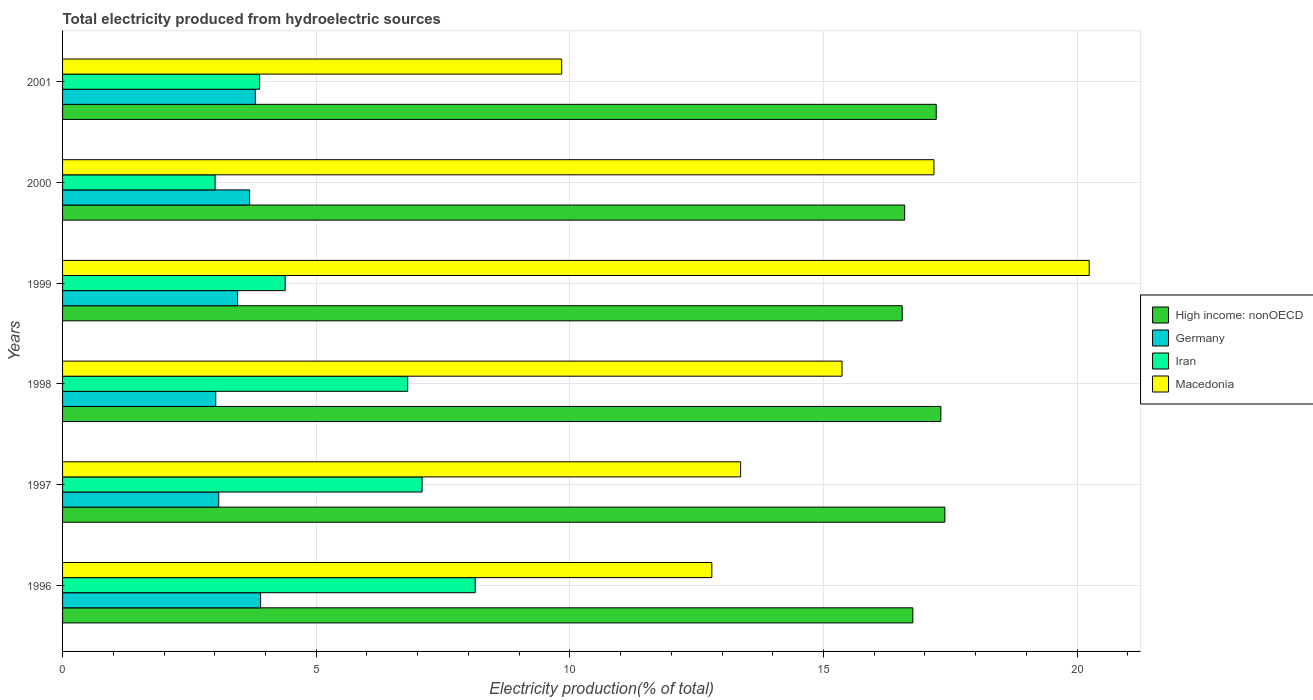Are the number of bars per tick equal to the number of legend labels?
Keep it short and to the point. Yes. Are the number of bars on each tick of the Y-axis equal?
Provide a succinct answer. Yes. How many bars are there on the 1st tick from the bottom?
Provide a succinct answer. 4. What is the label of the 1st group of bars from the top?
Provide a succinct answer. 2001. What is the total electricity produced in Iran in 2001?
Your answer should be compact. 3.88. Across all years, what is the maximum total electricity produced in High income: nonOECD?
Offer a terse response. 17.39. Across all years, what is the minimum total electricity produced in Macedonia?
Offer a very short reply. 9.84. What is the total total electricity produced in Germany in the graph?
Ensure brevity in your answer.  20.94. What is the difference between the total electricity produced in Iran in 1997 and that in 1999?
Your answer should be very brief. 2.7. What is the difference between the total electricity produced in Iran in 1996 and the total electricity produced in Germany in 2001?
Provide a succinct answer. 4.34. What is the average total electricity produced in Macedonia per year?
Your response must be concise. 14.8. In the year 1998, what is the difference between the total electricity produced in High income: nonOECD and total electricity produced in Macedonia?
Your response must be concise. 1.95. What is the ratio of the total electricity produced in High income: nonOECD in 1997 to that in 1999?
Ensure brevity in your answer.  1.05. What is the difference between the highest and the second highest total electricity produced in Macedonia?
Your response must be concise. 3.06. What is the difference between the highest and the lowest total electricity produced in Germany?
Your answer should be very brief. 0.88. In how many years, is the total electricity produced in Macedonia greater than the average total electricity produced in Macedonia taken over all years?
Keep it short and to the point. 3. Is the sum of the total electricity produced in Germany in 1998 and 1999 greater than the maximum total electricity produced in Iran across all years?
Provide a short and direct response. No. Is it the case that in every year, the sum of the total electricity produced in Iran and total electricity produced in Germany is greater than the sum of total electricity produced in Macedonia and total electricity produced in High income: nonOECD?
Your response must be concise. No. What does the 2nd bar from the top in 1998 represents?
Your answer should be very brief. Iran. What does the 4th bar from the bottom in 1996 represents?
Offer a very short reply. Macedonia. How many legend labels are there?
Provide a succinct answer. 4. What is the title of the graph?
Offer a very short reply. Total electricity produced from hydroelectric sources. Does "Sierra Leone" appear as one of the legend labels in the graph?
Your answer should be very brief. No. What is the Electricity production(% of total) in High income: nonOECD in 1996?
Keep it short and to the point. 16.76. What is the Electricity production(% of total) of Germany in 1996?
Offer a terse response. 3.9. What is the Electricity production(% of total) of Iran in 1996?
Your answer should be very brief. 8.13. What is the Electricity production(% of total) of Macedonia in 1996?
Give a very brief answer. 12.8. What is the Electricity production(% of total) of High income: nonOECD in 1997?
Provide a succinct answer. 17.39. What is the Electricity production(% of total) of Germany in 1997?
Offer a terse response. 3.08. What is the Electricity production(% of total) in Iran in 1997?
Make the answer very short. 7.09. What is the Electricity production(% of total) in Macedonia in 1997?
Offer a very short reply. 13.37. What is the Electricity production(% of total) of High income: nonOECD in 1998?
Offer a very short reply. 17.31. What is the Electricity production(% of total) in Germany in 1998?
Ensure brevity in your answer.  3.02. What is the Electricity production(% of total) in Iran in 1998?
Give a very brief answer. 6.8. What is the Electricity production(% of total) of Macedonia in 1998?
Make the answer very short. 15.37. What is the Electricity production(% of total) in High income: nonOECD in 1999?
Provide a short and direct response. 16.55. What is the Electricity production(% of total) in Germany in 1999?
Provide a short and direct response. 3.45. What is the Electricity production(% of total) in Iran in 1999?
Ensure brevity in your answer.  4.39. What is the Electricity production(% of total) of Macedonia in 1999?
Ensure brevity in your answer.  20.24. What is the Electricity production(% of total) of High income: nonOECD in 2000?
Make the answer very short. 16.6. What is the Electricity production(% of total) of Germany in 2000?
Make the answer very short. 3.69. What is the Electricity production(% of total) in Iran in 2000?
Ensure brevity in your answer.  3.01. What is the Electricity production(% of total) of Macedonia in 2000?
Offer a very short reply. 17.18. What is the Electricity production(% of total) in High income: nonOECD in 2001?
Offer a very short reply. 17.22. What is the Electricity production(% of total) in Germany in 2001?
Make the answer very short. 3.8. What is the Electricity production(% of total) of Iran in 2001?
Give a very brief answer. 3.88. What is the Electricity production(% of total) in Macedonia in 2001?
Keep it short and to the point. 9.84. Across all years, what is the maximum Electricity production(% of total) in High income: nonOECD?
Keep it short and to the point. 17.39. Across all years, what is the maximum Electricity production(% of total) in Germany?
Your answer should be compact. 3.9. Across all years, what is the maximum Electricity production(% of total) in Iran?
Offer a very short reply. 8.13. Across all years, what is the maximum Electricity production(% of total) in Macedonia?
Your answer should be very brief. 20.24. Across all years, what is the minimum Electricity production(% of total) of High income: nonOECD?
Your answer should be very brief. 16.55. Across all years, what is the minimum Electricity production(% of total) in Germany?
Your answer should be very brief. 3.02. Across all years, what is the minimum Electricity production(% of total) of Iran?
Give a very brief answer. 3.01. Across all years, what is the minimum Electricity production(% of total) in Macedonia?
Provide a short and direct response. 9.84. What is the total Electricity production(% of total) in High income: nonOECD in the graph?
Keep it short and to the point. 101.85. What is the total Electricity production(% of total) of Germany in the graph?
Provide a succinct answer. 20.94. What is the total Electricity production(% of total) of Iran in the graph?
Provide a succinct answer. 33.31. What is the total Electricity production(% of total) in Macedonia in the graph?
Your answer should be very brief. 88.79. What is the difference between the Electricity production(% of total) of High income: nonOECD in 1996 and that in 1997?
Offer a very short reply. -0.63. What is the difference between the Electricity production(% of total) in Germany in 1996 and that in 1997?
Give a very brief answer. 0.82. What is the difference between the Electricity production(% of total) of Iran in 1996 and that in 1997?
Ensure brevity in your answer.  1.05. What is the difference between the Electricity production(% of total) of Macedonia in 1996 and that in 1997?
Keep it short and to the point. -0.57. What is the difference between the Electricity production(% of total) of High income: nonOECD in 1996 and that in 1998?
Provide a short and direct response. -0.55. What is the difference between the Electricity production(% of total) in Germany in 1996 and that in 1998?
Make the answer very short. 0.88. What is the difference between the Electricity production(% of total) in Iran in 1996 and that in 1998?
Provide a succinct answer. 1.33. What is the difference between the Electricity production(% of total) of Macedonia in 1996 and that in 1998?
Make the answer very short. -2.57. What is the difference between the Electricity production(% of total) in High income: nonOECD in 1996 and that in 1999?
Ensure brevity in your answer.  0.21. What is the difference between the Electricity production(% of total) of Germany in 1996 and that in 1999?
Give a very brief answer. 0.45. What is the difference between the Electricity production(% of total) of Iran in 1996 and that in 1999?
Provide a succinct answer. 3.75. What is the difference between the Electricity production(% of total) of Macedonia in 1996 and that in 1999?
Offer a very short reply. -7.44. What is the difference between the Electricity production(% of total) of High income: nonOECD in 1996 and that in 2000?
Offer a very short reply. 0.16. What is the difference between the Electricity production(% of total) in Germany in 1996 and that in 2000?
Give a very brief answer. 0.22. What is the difference between the Electricity production(% of total) in Iran in 1996 and that in 2000?
Keep it short and to the point. 5.13. What is the difference between the Electricity production(% of total) of Macedonia in 1996 and that in 2000?
Offer a very short reply. -4.38. What is the difference between the Electricity production(% of total) in High income: nonOECD in 1996 and that in 2001?
Provide a succinct answer. -0.46. What is the difference between the Electricity production(% of total) in Germany in 1996 and that in 2001?
Make the answer very short. 0.1. What is the difference between the Electricity production(% of total) in Iran in 1996 and that in 2001?
Provide a short and direct response. 4.25. What is the difference between the Electricity production(% of total) in Macedonia in 1996 and that in 2001?
Your answer should be compact. 2.96. What is the difference between the Electricity production(% of total) of High income: nonOECD in 1997 and that in 1998?
Offer a very short reply. 0.08. What is the difference between the Electricity production(% of total) in Germany in 1997 and that in 1998?
Provide a short and direct response. 0.06. What is the difference between the Electricity production(% of total) in Iran in 1997 and that in 1998?
Give a very brief answer. 0.28. What is the difference between the Electricity production(% of total) in Macedonia in 1997 and that in 1998?
Your answer should be very brief. -2. What is the difference between the Electricity production(% of total) of High income: nonOECD in 1997 and that in 1999?
Provide a succinct answer. 0.84. What is the difference between the Electricity production(% of total) of Germany in 1997 and that in 1999?
Your answer should be very brief. -0.37. What is the difference between the Electricity production(% of total) in Iran in 1997 and that in 1999?
Make the answer very short. 2.7. What is the difference between the Electricity production(% of total) of Macedonia in 1997 and that in 1999?
Offer a very short reply. -6.87. What is the difference between the Electricity production(% of total) of High income: nonOECD in 1997 and that in 2000?
Offer a terse response. 0.79. What is the difference between the Electricity production(% of total) in Germany in 1997 and that in 2000?
Make the answer very short. -0.61. What is the difference between the Electricity production(% of total) in Iran in 1997 and that in 2000?
Provide a short and direct response. 4.08. What is the difference between the Electricity production(% of total) in Macedonia in 1997 and that in 2000?
Give a very brief answer. -3.81. What is the difference between the Electricity production(% of total) of High income: nonOECD in 1997 and that in 2001?
Provide a short and direct response. 0.17. What is the difference between the Electricity production(% of total) of Germany in 1997 and that in 2001?
Ensure brevity in your answer.  -0.72. What is the difference between the Electricity production(% of total) in Iran in 1997 and that in 2001?
Your response must be concise. 3.2. What is the difference between the Electricity production(% of total) in Macedonia in 1997 and that in 2001?
Offer a very short reply. 3.53. What is the difference between the Electricity production(% of total) in High income: nonOECD in 1998 and that in 1999?
Give a very brief answer. 0.76. What is the difference between the Electricity production(% of total) of Germany in 1998 and that in 1999?
Your answer should be very brief. -0.43. What is the difference between the Electricity production(% of total) of Iran in 1998 and that in 1999?
Your response must be concise. 2.42. What is the difference between the Electricity production(% of total) of Macedonia in 1998 and that in 1999?
Make the answer very short. -4.87. What is the difference between the Electricity production(% of total) of High income: nonOECD in 1998 and that in 2000?
Your response must be concise. 0.71. What is the difference between the Electricity production(% of total) of Germany in 1998 and that in 2000?
Offer a very short reply. -0.67. What is the difference between the Electricity production(% of total) of Iran in 1998 and that in 2000?
Offer a very short reply. 3.8. What is the difference between the Electricity production(% of total) of Macedonia in 1998 and that in 2000?
Provide a succinct answer. -1.81. What is the difference between the Electricity production(% of total) of High income: nonOECD in 1998 and that in 2001?
Offer a terse response. 0.09. What is the difference between the Electricity production(% of total) in Germany in 1998 and that in 2001?
Ensure brevity in your answer.  -0.78. What is the difference between the Electricity production(% of total) of Iran in 1998 and that in 2001?
Keep it short and to the point. 2.92. What is the difference between the Electricity production(% of total) in Macedonia in 1998 and that in 2001?
Give a very brief answer. 5.53. What is the difference between the Electricity production(% of total) in High income: nonOECD in 1999 and that in 2000?
Make the answer very short. -0.05. What is the difference between the Electricity production(% of total) of Germany in 1999 and that in 2000?
Offer a terse response. -0.24. What is the difference between the Electricity production(% of total) of Iran in 1999 and that in 2000?
Offer a terse response. 1.38. What is the difference between the Electricity production(% of total) of Macedonia in 1999 and that in 2000?
Give a very brief answer. 3.06. What is the difference between the Electricity production(% of total) in High income: nonOECD in 1999 and that in 2001?
Make the answer very short. -0.67. What is the difference between the Electricity production(% of total) of Germany in 1999 and that in 2001?
Offer a very short reply. -0.35. What is the difference between the Electricity production(% of total) in Iran in 1999 and that in 2001?
Offer a very short reply. 0.5. What is the difference between the Electricity production(% of total) of Macedonia in 1999 and that in 2001?
Your answer should be very brief. 10.4. What is the difference between the Electricity production(% of total) of High income: nonOECD in 2000 and that in 2001?
Your answer should be compact. -0.62. What is the difference between the Electricity production(% of total) of Germany in 2000 and that in 2001?
Ensure brevity in your answer.  -0.11. What is the difference between the Electricity production(% of total) in Iran in 2000 and that in 2001?
Give a very brief answer. -0.88. What is the difference between the Electricity production(% of total) of Macedonia in 2000 and that in 2001?
Offer a terse response. 7.34. What is the difference between the Electricity production(% of total) of High income: nonOECD in 1996 and the Electricity production(% of total) of Germany in 1997?
Provide a short and direct response. 13.68. What is the difference between the Electricity production(% of total) in High income: nonOECD in 1996 and the Electricity production(% of total) in Iran in 1997?
Your response must be concise. 9.67. What is the difference between the Electricity production(% of total) in High income: nonOECD in 1996 and the Electricity production(% of total) in Macedonia in 1997?
Keep it short and to the point. 3.39. What is the difference between the Electricity production(% of total) of Germany in 1996 and the Electricity production(% of total) of Iran in 1997?
Your response must be concise. -3.18. What is the difference between the Electricity production(% of total) in Germany in 1996 and the Electricity production(% of total) in Macedonia in 1997?
Your answer should be very brief. -9.46. What is the difference between the Electricity production(% of total) in Iran in 1996 and the Electricity production(% of total) in Macedonia in 1997?
Provide a short and direct response. -5.23. What is the difference between the Electricity production(% of total) of High income: nonOECD in 1996 and the Electricity production(% of total) of Germany in 1998?
Ensure brevity in your answer.  13.74. What is the difference between the Electricity production(% of total) of High income: nonOECD in 1996 and the Electricity production(% of total) of Iran in 1998?
Offer a very short reply. 9.96. What is the difference between the Electricity production(% of total) of High income: nonOECD in 1996 and the Electricity production(% of total) of Macedonia in 1998?
Provide a succinct answer. 1.4. What is the difference between the Electricity production(% of total) in Germany in 1996 and the Electricity production(% of total) in Iran in 1998?
Ensure brevity in your answer.  -2.9. What is the difference between the Electricity production(% of total) in Germany in 1996 and the Electricity production(% of total) in Macedonia in 1998?
Ensure brevity in your answer.  -11.46. What is the difference between the Electricity production(% of total) in Iran in 1996 and the Electricity production(% of total) in Macedonia in 1998?
Provide a succinct answer. -7.23. What is the difference between the Electricity production(% of total) in High income: nonOECD in 1996 and the Electricity production(% of total) in Germany in 1999?
Your answer should be very brief. 13.31. What is the difference between the Electricity production(% of total) of High income: nonOECD in 1996 and the Electricity production(% of total) of Iran in 1999?
Offer a terse response. 12.37. What is the difference between the Electricity production(% of total) in High income: nonOECD in 1996 and the Electricity production(% of total) in Macedonia in 1999?
Provide a short and direct response. -3.48. What is the difference between the Electricity production(% of total) of Germany in 1996 and the Electricity production(% of total) of Iran in 1999?
Provide a short and direct response. -0.48. What is the difference between the Electricity production(% of total) in Germany in 1996 and the Electricity production(% of total) in Macedonia in 1999?
Provide a succinct answer. -16.34. What is the difference between the Electricity production(% of total) in Iran in 1996 and the Electricity production(% of total) in Macedonia in 1999?
Make the answer very short. -12.1. What is the difference between the Electricity production(% of total) of High income: nonOECD in 1996 and the Electricity production(% of total) of Germany in 2000?
Your answer should be compact. 13.07. What is the difference between the Electricity production(% of total) of High income: nonOECD in 1996 and the Electricity production(% of total) of Iran in 2000?
Make the answer very short. 13.75. What is the difference between the Electricity production(% of total) in High income: nonOECD in 1996 and the Electricity production(% of total) in Macedonia in 2000?
Your response must be concise. -0.42. What is the difference between the Electricity production(% of total) of Germany in 1996 and the Electricity production(% of total) of Iran in 2000?
Your answer should be compact. 0.9. What is the difference between the Electricity production(% of total) in Germany in 1996 and the Electricity production(% of total) in Macedonia in 2000?
Your answer should be compact. -13.27. What is the difference between the Electricity production(% of total) in Iran in 1996 and the Electricity production(% of total) in Macedonia in 2000?
Ensure brevity in your answer.  -9.04. What is the difference between the Electricity production(% of total) in High income: nonOECD in 1996 and the Electricity production(% of total) in Germany in 2001?
Offer a very short reply. 12.96. What is the difference between the Electricity production(% of total) of High income: nonOECD in 1996 and the Electricity production(% of total) of Iran in 2001?
Offer a very short reply. 12.88. What is the difference between the Electricity production(% of total) in High income: nonOECD in 1996 and the Electricity production(% of total) in Macedonia in 2001?
Offer a very short reply. 6.92. What is the difference between the Electricity production(% of total) in Germany in 1996 and the Electricity production(% of total) in Iran in 2001?
Give a very brief answer. 0.02. What is the difference between the Electricity production(% of total) in Germany in 1996 and the Electricity production(% of total) in Macedonia in 2001?
Offer a terse response. -5.94. What is the difference between the Electricity production(% of total) in Iran in 1996 and the Electricity production(% of total) in Macedonia in 2001?
Offer a very short reply. -1.7. What is the difference between the Electricity production(% of total) in High income: nonOECD in 1997 and the Electricity production(% of total) in Germany in 1998?
Your answer should be very brief. 14.37. What is the difference between the Electricity production(% of total) in High income: nonOECD in 1997 and the Electricity production(% of total) in Iran in 1998?
Offer a very short reply. 10.59. What is the difference between the Electricity production(% of total) of High income: nonOECD in 1997 and the Electricity production(% of total) of Macedonia in 1998?
Give a very brief answer. 2.03. What is the difference between the Electricity production(% of total) in Germany in 1997 and the Electricity production(% of total) in Iran in 1998?
Keep it short and to the point. -3.73. What is the difference between the Electricity production(% of total) in Germany in 1997 and the Electricity production(% of total) in Macedonia in 1998?
Your answer should be compact. -12.29. What is the difference between the Electricity production(% of total) of Iran in 1997 and the Electricity production(% of total) of Macedonia in 1998?
Make the answer very short. -8.28. What is the difference between the Electricity production(% of total) in High income: nonOECD in 1997 and the Electricity production(% of total) in Germany in 1999?
Your response must be concise. 13.94. What is the difference between the Electricity production(% of total) in High income: nonOECD in 1997 and the Electricity production(% of total) in Iran in 1999?
Your answer should be compact. 13.01. What is the difference between the Electricity production(% of total) in High income: nonOECD in 1997 and the Electricity production(% of total) in Macedonia in 1999?
Your response must be concise. -2.85. What is the difference between the Electricity production(% of total) of Germany in 1997 and the Electricity production(% of total) of Iran in 1999?
Ensure brevity in your answer.  -1.31. What is the difference between the Electricity production(% of total) of Germany in 1997 and the Electricity production(% of total) of Macedonia in 1999?
Offer a terse response. -17.16. What is the difference between the Electricity production(% of total) of Iran in 1997 and the Electricity production(% of total) of Macedonia in 1999?
Your response must be concise. -13.15. What is the difference between the Electricity production(% of total) in High income: nonOECD in 1997 and the Electricity production(% of total) in Germany in 2000?
Give a very brief answer. 13.71. What is the difference between the Electricity production(% of total) in High income: nonOECD in 1997 and the Electricity production(% of total) in Iran in 2000?
Offer a terse response. 14.39. What is the difference between the Electricity production(% of total) in High income: nonOECD in 1997 and the Electricity production(% of total) in Macedonia in 2000?
Make the answer very short. 0.22. What is the difference between the Electricity production(% of total) of Germany in 1997 and the Electricity production(% of total) of Iran in 2000?
Offer a very short reply. 0.07. What is the difference between the Electricity production(% of total) of Germany in 1997 and the Electricity production(% of total) of Macedonia in 2000?
Provide a short and direct response. -14.1. What is the difference between the Electricity production(% of total) in Iran in 1997 and the Electricity production(% of total) in Macedonia in 2000?
Your answer should be very brief. -10.09. What is the difference between the Electricity production(% of total) of High income: nonOECD in 1997 and the Electricity production(% of total) of Germany in 2001?
Keep it short and to the point. 13.59. What is the difference between the Electricity production(% of total) in High income: nonOECD in 1997 and the Electricity production(% of total) in Iran in 2001?
Give a very brief answer. 13.51. What is the difference between the Electricity production(% of total) of High income: nonOECD in 1997 and the Electricity production(% of total) of Macedonia in 2001?
Offer a very short reply. 7.55. What is the difference between the Electricity production(% of total) of Germany in 1997 and the Electricity production(% of total) of Iran in 2001?
Your response must be concise. -0.81. What is the difference between the Electricity production(% of total) in Germany in 1997 and the Electricity production(% of total) in Macedonia in 2001?
Ensure brevity in your answer.  -6.76. What is the difference between the Electricity production(% of total) of Iran in 1997 and the Electricity production(% of total) of Macedonia in 2001?
Your answer should be very brief. -2.75. What is the difference between the Electricity production(% of total) of High income: nonOECD in 1998 and the Electricity production(% of total) of Germany in 1999?
Make the answer very short. 13.86. What is the difference between the Electricity production(% of total) in High income: nonOECD in 1998 and the Electricity production(% of total) in Iran in 1999?
Make the answer very short. 12.93. What is the difference between the Electricity production(% of total) of High income: nonOECD in 1998 and the Electricity production(% of total) of Macedonia in 1999?
Your response must be concise. -2.93. What is the difference between the Electricity production(% of total) in Germany in 1998 and the Electricity production(% of total) in Iran in 1999?
Your response must be concise. -1.37. What is the difference between the Electricity production(% of total) in Germany in 1998 and the Electricity production(% of total) in Macedonia in 1999?
Make the answer very short. -17.22. What is the difference between the Electricity production(% of total) of Iran in 1998 and the Electricity production(% of total) of Macedonia in 1999?
Your answer should be very brief. -13.43. What is the difference between the Electricity production(% of total) in High income: nonOECD in 1998 and the Electricity production(% of total) in Germany in 2000?
Provide a succinct answer. 13.63. What is the difference between the Electricity production(% of total) of High income: nonOECD in 1998 and the Electricity production(% of total) of Iran in 2000?
Give a very brief answer. 14.31. What is the difference between the Electricity production(% of total) in High income: nonOECD in 1998 and the Electricity production(% of total) in Macedonia in 2000?
Your answer should be very brief. 0.14. What is the difference between the Electricity production(% of total) in Germany in 1998 and the Electricity production(% of total) in Iran in 2000?
Provide a succinct answer. 0.01. What is the difference between the Electricity production(% of total) in Germany in 1998 and the Electricity production(% of total) in Macedonia in 2000?
Your answer should be compact. -14.16. What is the difference between the Electricity production(% of total) of Iran in 1998 and the Electricity production(% of total) of Macedonia in 2000?
Keep it short and to the point. -10.37. What is the difference between the Electricity production(% of total) in High income: nonOECD in 1998 and the Electricity production(% of total) in Germany in 2001?
Ensure brevity in your answer.  13.51. What is the difference between the Electricity production(% of total) in High income: nonOECD in 1998 and the Electricity production(% of total) in Iran in 2001?
Offer a terse response. 13.43. What is the difference between the Electricity production(% of total) in High income: nonOECD in 1998 and the Electricity production(% of total) in Macedonia in 2001?
Your answer should be compact. 7.47. What is the difference between the Electricity production(% of total) in Germany in 1998 and the Electricity production(% of total) in Iran in 2001?
Keep it short and to the point. -0.86. What is the difference between the Electricity production(% of total) of Germany in 1998 and the Electricity production(% of total) of Macedonia in 2001?
Offer a terse response. -6.82. What is the difference between the Electricity production(% of total) of Iran in 1998 and the Electricity production(% of total) of Macedonia in 2001?
Make the answer very short. -3.04. What is the difference between the Electricity production(% of total) of High income: nonOECD in 1999 and the Electricity production(% of total) of Germany in 2000?
Ensure brevity in your answer.  12.87. What is the difference between the Electricity production(% of total) of High income: nonOECD in 1999 and the Electricity production(% of total) of Iran in 2000?
Make the answer very short. 13.55. What is the difference between the Electricity production(% of total) of High income: nonOECD in 1999 and the Electricity production(% of total) of Macedonia in 2000?
Provide a succinct answer. -0.62. What is the difference between the Electricity production(% of total) in Germany in 1999 and the Electricity production(% of total) in Iran in 2000?
Ensure brevity in your answer.  0.44. What is the difference between the Electricity production(% of total) of Germany in 1999 and the Electricity production(% of total) of Macedonia in 2000?
Keep it short and to the point. -13.73. What is the difference between the Electricity production(% of total) in Iran in 1999 and the Electricity production(% of total) in Macedonia in 2000?
Keep it short and to the point. -12.79. What is the difference between the Electricity production(% of total) in High income: nonOECD in 1999 and the Electricity production(% of total) in Germany in 2001?
Provide a short and direct response. 12.75. What is the difference between the Electricity production(% of total) of High income: nonOECD in 1999 and the Electricity production(% of total) of Iran in 2001?
Your response must be concise. 12.67. What is the difference between the Electricity production(% of total) in High income: nonOECD in 1999 and the Electricity production(% of total) in Macedonia in 2001?
Offer a terse response. 6.71. What is the difference between the Electricity production(% of total) in Germany in 1999 and the Electricity production(% of total) in Iran in 2001?
Provide a short and direct response. -0.43. What is the difference between the Electricity production(% of total) of Germany in 1999 and the Electricity production(% of total) of Macedonia in 2001?
Your answer should be very brief. -6.39. What is the difference between the Electricity production(% of total) in Iran in 1999 and the Electricity production(% of total) in Macedonia in 2001?
Ensure brevity in your answer.  -5.45. What is the difference between the Electricity production(% of total) of High income: nonOECD in 2000 and the Electricity production(% of total) of Germany in 2001?
Offer a very short reply. 12.8. What is the difference between the Electricity production(% of total) of High income: nonOECD in 2000 and the Electricity production(% of total) of Iran in 2001?
Ensure brevity in your answer.  12.72. What is the difference between the Electricity production(% of total) in High income: nonOECD in 2000 and the Electricity production(% of total) in Macedonia in 2001?
Your response must be concise. 6.76. What is the difference between the Electricity production(% of total) in Germany in 2000 and the Electricity production(% of total) in Iran in 2001?
Provide a succinct answer. -0.2. What is the difference between the Electricity production(% of total) in Germany in 2000 and the Electricity production(% of total) in Macedonia in 2001?
Keep it short and to the point. -6.15. What is the difference between the Electricity production(% of total) in Iran in 2000 and the Electricity production(% of total) in Macedonia in 2001?
Provide a succinct answer. -6.83. What is the average Electricity production(% of total) of High income: nonOECD per year?
Provide a succinct answer. 16.97. What is the average Electricity production(% of total) of Germany per year?
Ensure brevity in your answer.  3.49. What is the average Electricity production(% of total) in Iran per year?
Offer a terse response. 5.55. What is the average Electricity production(% of total) in Macedonia per year?
Keep it short and to the point. 14.8. In the year 1996, what is the difference between the Electricity production(% of total) in High income: nonOECD and Electricity production(% of total) in Germany?
Provide a short and direct response. 12.86. In the year 1996, what is the difference between the Electricity production(% of total) of High income: nonOECD and Electricity production(% of total) of Iran?
Keep it short and to the point. 8.63. In the year 1996, what is the difference between the Electricity production(% of total) in High income: nonOECD and Electricity production(% of total) in Macedonia?
Provide a succinct answer. 3.96. In the year 1996, what is the difference between the Electricity production(% of total) in Germany and Electricity production(% of total) in Iran?
Keep it short and to the point. -4.23. In the year 1996, what is the difference between the Electricity production(% of total) of Germany and Electricity production(% of total) of Macedonia?
Provide a short and direct response. -8.9. In the year 1996, what is the difference between the Electricity production(% of total) of Iran and Electricity production(% of total) of Macedonia?
Your response must be concise. -4.66. In the year 1997, what is the difference between the Electricity production(% of total) in High income: nonOECD and Electricity production(% of total) in Germany?
Give a very brief answer. 14.31. In the year 1997, what is the difference between the Electricity production(% of total) of High income: nonOECD and Electricity production(% of total) of Iran?
Your answer should be very brief. 10.31. In the year 1997, what is the difference between the Electricity production(% of total) in High income: nonOECD and Electricity production(% of total) in Macedonia?
Offer a terse response. 4.03. In the year 1997, what is the difference between the Electricity production(% of total) of Germany and Electricity production(% of total) of Iran?
Give a very brief answer. -4.01. In the year 1997, what is the difference between the Electricity production(% of total) of Germany and Electricity production(% of total) of Macedonia?
Your response must be concise. -10.29. In the year 1997, what is the difference between the Electricity production(% of total) of Iran and Electricity production(% of total) of Macedonia?
Provide a short and direct response. -6.28. In the year 1998, what is the difference between the Electricity production(% of total) in High income: nonOECD and Electricity production(% of total) in Germany?
Ensure brevity in your answer.  14.29. In the year 1998, what is the difference between the Electricity production(% of total) in High income: nonOECD and Electricity production(% of total) in Iran?
Your answer should be very brief. 10.51. In the year 1998, what is the difference between the Electricity production(% of total) of High income: nonOECD and Electricity production(% of total) of Macedonia?
Provide a succinct answer. 1.95. In the year 1998, what is the difference between the Electricity production(% of total) in Germany and Electricity production(% of total) in Iran?
Offer a very short reply. -3.78. In the year 1998, what is the difference between the Electricity production(% of total) of Germany and Electricity production(% of total) of Macedonia?
Ensure brevity in your answer.  -12.35. In the year 1998, what is the difference between the Electricity production(% of total) in Iran and Electricity production(% of total) in Macedonia?
Offer a very short reply. -8.56. In the year 1999, what is the difference between the Electricity production(% of total) in High income: nonOECD and Electricity production(% of total) in Germany?
Ensure brevity in your answer.  13.1. In the year 1999, what is the difference between the Electricity production(% of total) of High income: nonOECD and Electricity production(% of total) of Iran?
Offer a very short reply. 12.16. In the year 1999, what is the difference between the Electricity production(% of total) of High income: nonOECD and Electricity production(% of total) of Macedonia?
Give a very brief answer. -3.69. In the year 1999, what is the difference between the Electricity production(% of total) in Germany and Electricity production(% of total) in Iran?
Provide a succinct answer. -0.94. In the year 1999, what is the difference between the Electricity production(% of total) in Germany and Electricity production(% of total) in Macedonia?
Make the answer very short. -16.79. In the year 1999, what is the difference between the Electricity production(% of total) of Iran and Electricity production(% of total) of Macedonia?
Keep it short and to the point. -15.85. In the year 2000, what is the difference between the Electricity production(% of total) of High income: nonOECD and Electricity production(% of total) of Germany?
Ensure brevity in your answer.  12.91. In the year 2000, what is the difference between the Electricity production(% of total) of High income: nonOECD and Electricity production(% of total) of Iran?
Give a very brief answer. 13.59. In the year 2000, what is the difference between the Electricity production(% of total) of High income: nonOECD and Electricity production(% of total) of Macedonia?
Offer a terse response. -0.58. In the year 2000, what is the difference between the Electricity production(% of total) of Germany and Electricity production(% of total) of Iran?
Offer a very short reply. 0.68. In the year 2000, what is the difference between the Electricity production(% of total) of Germany and Electricity production(% of total) of Macedonia?
Keep it short and to the point. -13.49. In the year 2000, what is the difference between the Electricity production(% of total) in Iran and Electricity production(% of total) in Macedonia?
Give a very brief answer. -14.17. In the year 2001, what is the difference between the Electricity production(% of total) in High income: nonOECD and Electricity production(% of total) in Germany?
Offer a terse response. 13.42. In the year 2001, what is the difference between the Electricity production(% of total) of High income: nonOECD and Electricity production(% of total) of Iran?
Provide a short and direct response. 13.34. In the year 2001, what is the difference between the Electricity production(% of total) of High income: nonOECD and Electricity production(% of total) of Macedonia?
Your answer should be very brief. 7.38. In the year 2001, what is the difference between the Electricity production(% of total) in Germany and Electricity production(% of total) in Iran?
Make the answer very short. -0.09. In the year 2001, what is the difference between the Electricity production(% of total) of Germany and Electricity production(% of total) of Macedonia?
Offer a terse response. -6.04. In the year 2001, what is the difference between the Electricity production(% of total) in Iran and Electricity production(% of total) in Macedonia?
Provide a succinct answer. -5.96. What is the ratio of the Electricity production(% of total) in High income: nonOECD in 1996 to that in 1997?
Your answer should be compact. 0.96. What is the ratio of the Electricity production(% of total) in Germany in 1996 to that in 1997?
Make the answer very short. 1.27. What is the ratio of the Electricity production(% of total) of Iran in 1996 to that in 1997?
Ensure brevity in your answer.  1.15. What is the ratio of the Electricity production(% of total) of Macedonia in 1996 to that in 1997?
Your answer should be very brief. 0.96. What is the ratio of the Electricity production(% of total) in High income: nonOECD in 1996 to that in 1998?
Keep it short and to the point. 0.97. What is the ratio of the Electricity production(% of total) of Germany in 1996 to that in 1998?
Offer a very short reply. 1.29. What is the ratio of the Electricity production(% of total) in Iran in 1996 to that in 1998?
Give a very brief answer. 1.2. What is the ratio of the Electricity production(% of total) in Macedonia in 1996 to that in 1998?
Keep it short and to the point. 0.83. What is the ratio of the Electricity production(% of total) in High income: nonOECD in 1996 to that in 1999?
Provide a short and direct response. 1.01. What is the ratio of the Electricity production(% of total) of Germany in 1996 to that in 1999?
Make the answer very short. 1.13. What is the ratio of the Electricity production(% of total) in Iran in 1996 to that in 1999?
Make the answer very short. 1.85. What is the ratio of the Electricity production(% of total) in Macedonia in 1996 to that in 1999?
Provide a succinct answer. 0.63. What is the ratio of the Electricity production(% of total) of High income: nonOECD in 1996 to that in 2000?
Provide a short and direct response. 1.01. What is the ratio of the Electricity production(% of total) of Germany in 1996 to that in 2000?
Keep it short and to the point. 1.06. What is the ratio of the Electricity production(% of total) of Iran in 1996 to that in 2000?
Keep it short and to the point. 2.71. What is the ratio of the Electricity production(% of total) in Macedonia in 1996 to that in 2000?
Your answer should be very brief. 0.75. What is the ratio of the Electricity production(% of total) of High income: nonOECD in 1996 to that in 2001?
Keep it short and to the point. 0.97. What is the ratio of the Electricity production(% of total) of Germany in 1996 to that in 2001?
Make the answer very short. 1.03. What is the ratio of the Electricity production(% of total) in Iran in 1996 to that in 2001?
Make the answer very short. 2.09. What is the ratio of the Electricity production(% of total) of Macedonia in 1996 to that in 2001?
Your answer should be very brief. 1.3. What is the ratio of the Electricity production(% of total) of High income: nonOECD in 1997 to that in 1998?
Offer a very short reply. 1. What is the ratio of the Electricity production(% of total) of Germany in 1997 to that in 1998?
Ensure brevity in your answer.  1.02. What is the ratio of the Electricity production(% of total) in Iran in 1997 to that in 1998?
Provide a succinct answer. 1.04. What is the ratio of the Electricity production(% of total) of Macedonia in 1997 to that in 1998?
Keep it short and to the point. 0.87. What is the ratio of the Electricity production(% of total) of High income: nonOECD in 1997 to that in 1999?
Your answer should be very brief. 1.05. What is the ratio of the Electricity production(% of total) in Germany in 1997 to that in 1999?
Your answer should be very brief. 0.89. What is the ratio of the Electricity production(% of total) in Iran in 1997 to that in 1999?
Provide a short and direct response. 1.61. What is the ratio of the Electricity production(% of total) in Macedonia in 1997 to that in 1999?
Provide a short and direct response. 0.66. What is the ratio of the Electricity production(% of total) of High income: nonOECD in 1997 to that in 2000?
Your answer should be compact. 1.05. What is the ratio of the Electricity production(% of total) of Germany in 1997 to that in 2000?
Offer a very short reply. 0.83. What is the ratio of the Electricity production(% of total) in Iran in 1997 to that in 2000?
Offer a terse response. 2.36. What is the ratio of the Electricity production(% of total) of Macedonia in 1997 to that in 2000?
Your response must be concise. 0.78. What is the ratio of the Electricity production(% of total) of High income: nonOECD in 1997 to that in 2001?
Offer a terse response. 1.01. What is the ratio of the Electricity production(% of total) in Germany in 1997 to that in 2001?
Your answer should be very brief. 0.81. What is the ratio of the Electricity production(% of total) in Iran in 1997 to that in 2001?
Your answer should be very brief. 1.82. What is the ratio of the Electricity production(% of total) of Macedonia in 1997 to that in 2001?
Offer a very short reply. 1.36. What is the ratio of the Electricity production(% of total) of High income: nonOECD in 1998 to that in 1999?
Ensure brevity in your answer.  1.05. What is the ratio of the Electricity production(% of total) of Germany in 1998 to that in 1999?
Provide a succinct answer. 0.88. What is the ratio of the Electricity production(% of total) in Iran in 1998 to that in 1999?
Offer a very short reply. 1.55. What is the ratio of the Electricity production(% of total) of Macedonia in 1998 to that in 1999?
Give a very brief answer. 0.76. What is the ratio of the Electricity production(% of total) in High income: nonOECD in 1998 to that in 2000?
Offer a terse response. 1.04. What is the ratio of the Electricity production(% of total) in Germany in 1998 to that in 2000?
Provide a succinct answer. 0.82. What is the ratio of the Electricity production(% of total) in Iran in 1998 to that in 2000?
Your answer should be very brief. 2.26. What is the ratio of the Electricity production(% of total) in Macedonia in 1998 to that in 2000?
Your response must be concise. 0.89. What is the ratio of the Electricity production(% of total) in High income: nonOECD in 1998 to that in 2001?
Provide a succinct answer. 1.01. What is the ratio of the Electricity production(% of total) of Germany in 1998 to that in 2001?
Provide a short and direct response. 0.79. What is the ratio of the Electricity production(% of total) of Iran in 1998 to that in 2001?
Make the answer very short. 1.75. What is the ratio of the Electricity production(% of total) in Macedonia in 1998 to that in 2001?
Your answer should be very brief. 1.56. What is the ratio of the Electricity production(% of total) of High income: nonOECD in 1999 to that in 2000?
Give a very brief answer. 1. What is the ratio of the Electricity production(% of total) of Germany in 1999 to that in 2000?
Make the answer very short. 0.94. What is the ratio of the Electricity production(% of total) of Iran in 1999 to that in 2000?
Your response must be concise. 1.46. What is the ratio of the Electricity production(% of total) in Macedonia in 1999 to that in 2000?
Give a very brief answer. 1.18. What is the ratio of the Electricity production(% of total) in High income: nonOECD in 1999 to that in 2001?
Make the answer very short. 0.96. What is the ratio of the Electricity production(% of total) of Germany in 1999 to that in 2001?
Ensure brevity in your answer.  0.91. What is the ratio of the Electricity production(% of total) in Iran in 1999 to that in 2001?
Keep it short and to the point. 1.13. What is the ratio of the Electricity production(% of total) of Macedonia in 1999 to that in 2001?
Provide a succinct answer. 2.06. What is the ratio of the Electricity production(% of total) of High income: nonOECD in 2000 to that in 2001?
Provide a short and direct response. 0.96. What is the ratio of the Electricity production(% of total) of Germany in 2000 to that in 2001?
Keep it short and to the point. 0.97. What is the ratio of the Electricity production(% of total) of Iran in 2000 to that in 2001?
Provide a succinct answer. 0.77. What is the ratio of the Electricity production(% of total) in Macedonia in 2000 to that in 2001?
Your answer should be very brief. 1.75. What is the difference between the highest and the second highest Electricity production(% of total) of High income: nonOECD?
Your answer should be very brief. 0.08. What is the difference between the highest and the second highest Electricity production(% of total) in Germany?
Provide a succinct answer. 0.1. What is the difference between the highest and the second highest Electricity production(% of total) in Iran?
Provide a succinct answer. 1.05. What is the difference between the highest and the second highest Electricity production(% of total) in Macedonia?
Make the answer very short. 3.06. What is the difference between the highest and the lowest Electricity production(% of total) of High income: nonOECD?
Your answer should be very brief. 0.84. What is the difference between the highest and the lowest Electricity production(% of total) of Germany?
Your answer should be very brief. 0.88. What is the difference between the highest and the lowest Electricity production(% of total) in Iran?
Provide a short and direct response. 5.13. What is the difference between the highest and the lowest Electricity production(% of total) in Macedonia?
Offer a very short reply. 10.4. 